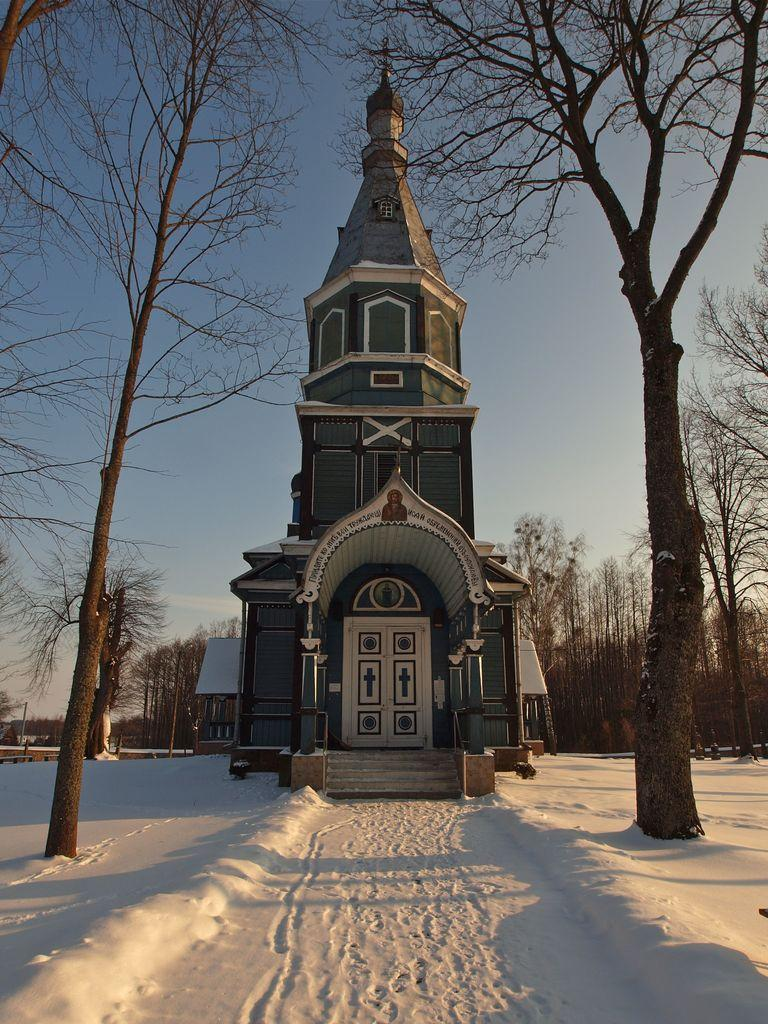What type of structures can be seen in the image? There are houses in the image. What other natural elements are present in the image? There are trees in the image. What is the weather condition in the image? There is snow visible in the image, indicating a cold or wintery setting. What can be seen in the background of the image? The sky is visible in the background of the image. What type of operation is being performed on the quartz in the image? There is no quartz or operation present in the image; it features houses, trees, snow, and the sky. Can you tell me the name of the brother who lives in one of the houses in the image? There is no information about the residents of the houses in the image, so it is not possible to determine the name of any brothers. 